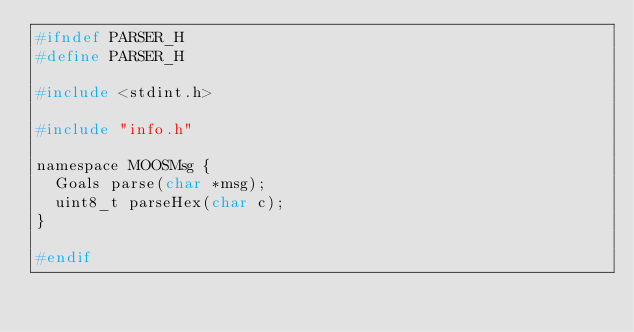<code> <loc_0><loc_0><loc_500><loc_500><_C_>#ifndef PARSER_H
#define PARSER_H

#include <stdint.h>

#include "info.h"

namespace MOOSMsg {
  Goals parse(char *msg);
  uint8_t parseHex(char c);
}

#endif
</code> 